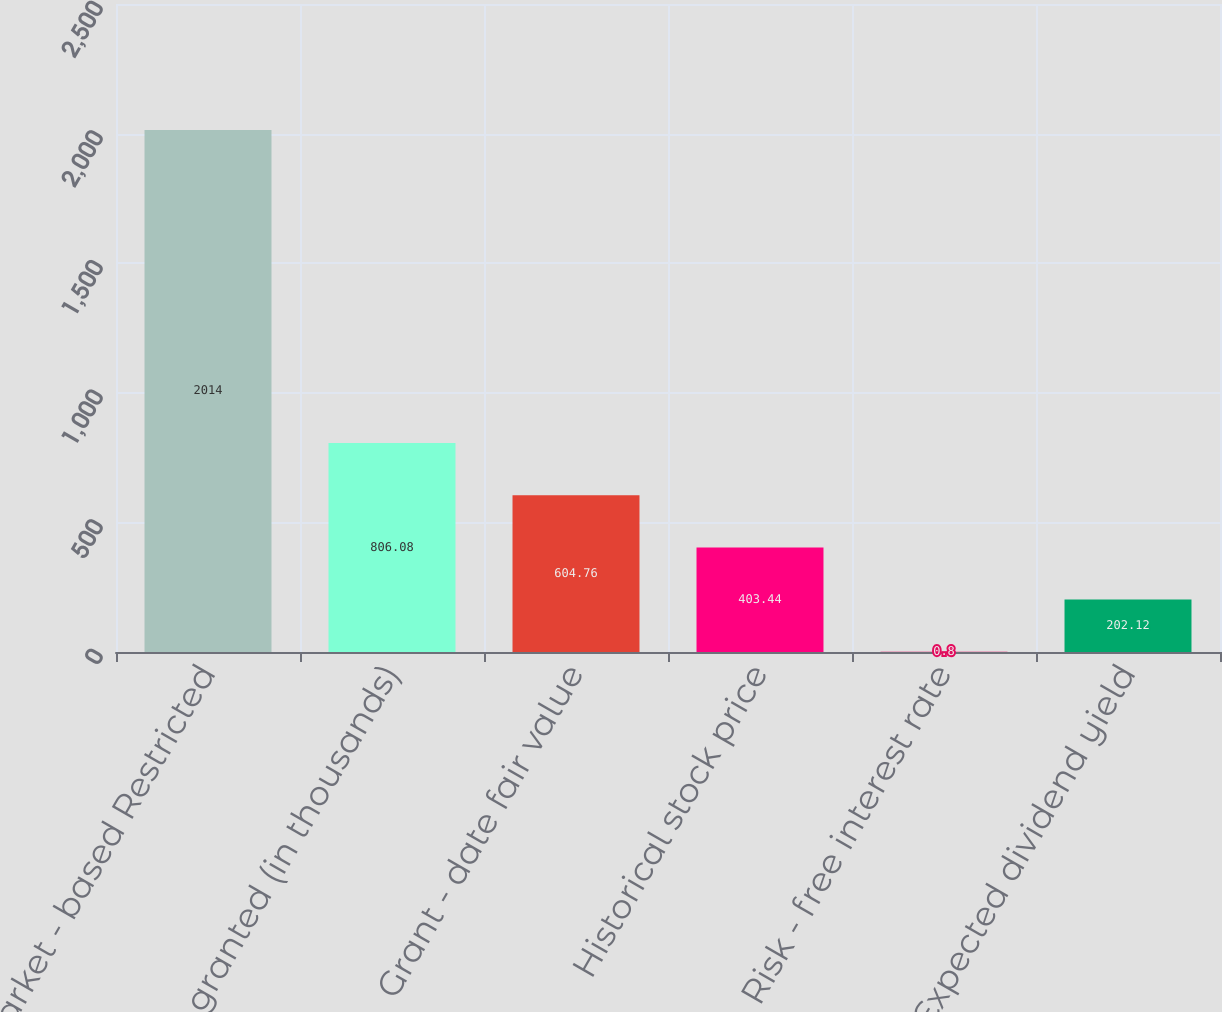<chart> <loc_0><loc_0><loc_500><loc_500><bar_chart><fcel>Market - based Restricted<fcel>Units granted (in thousands)<fcel>Grant - date fair value<fcel>Historical stock price<fcel>Risk - free interest rate<fcel>Expected dividend yield<nl><fcel>2014<fcel>806.08<fcel>604.76<fcel>403.44<fcel>0.8<fcel>202.12<nl></chart> 